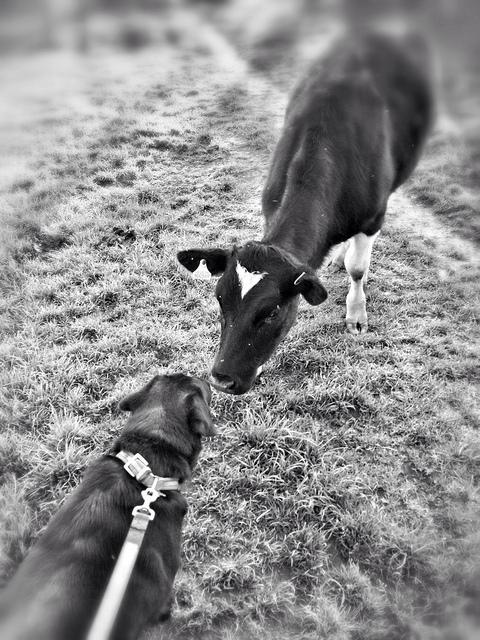What trait can be applied to both animals?
Write a very short answer. Black color. What animal is on the leash?
Concise answer only. Dog. Is this a black and white photo?
Short answer required. Yes. 